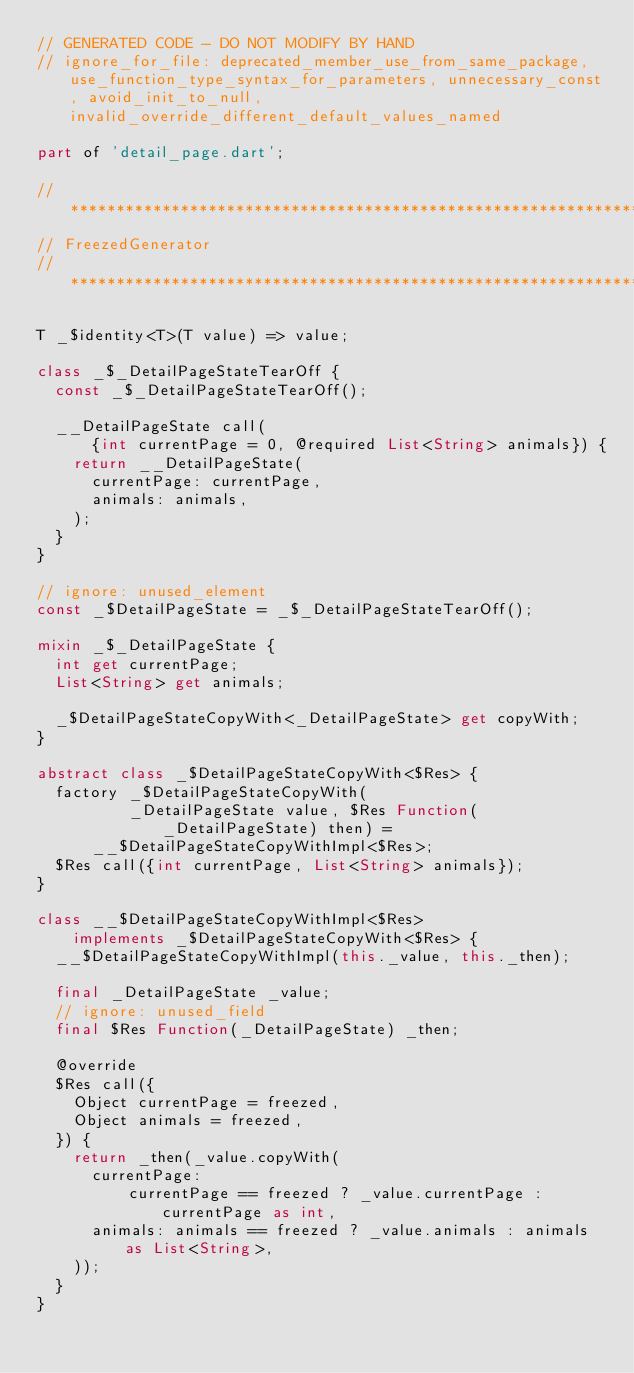<code> <loc_0><loc_0><loc_500><loc_500><_Dart_>// GENERATED CODE - DO NOT MODIFY BY HAND
// ignore_for_file: deprecated_member_use_from_same_package, use_function_type_syntax_for_parameters, unnecessary_const, avoid_init_to_null, invalid_override_different_default_values_named

part of 'detail_page.dart';

// **************************************************************************
// FreezedGenerator
// **************************************************************************

T _$identity<T>(T value) => value;

class _$_DetailPageStateTearOff {
  const _$_DetailPageStateTearOff();

  __DetailPageState call(
      {int currentPage = 0, @required List<String> animals}) {
    return __DetailPageState(
      currentPage: currentPage,
      animals: animals,
    );
  }
}

// ignore: unused_element
const _$DetailPageState = _$_DetailPageStateTearOff();

mixin _$_DetailPageState {
  int get currentPage;
  List<String> get animals;

  _$DetailPageStateCopyWith<_DetailPageState> get copyWith;
}

abstract class _$DetailPageStateCopyWith<$Res> {
  factory _$DetailPageStateCopyWith(
          _DetailPageState value, $Res Function(_DetailPageState) then) =
      __$DetailPageStateCopyWithImpl<$Res>;
  $Res call({int currentPage, List<String> animals});
}

class __$DetailPageStateCopyWithImpl<$Res>
    implements _$DetailPageStateCopyWith<$Res> {
  __$DetailPageStateCopyWithImpl(this._value, this._then);

  final _DetailPageState _value;
  // ignore: unused_field
  final $Res Function(_DetailPageState) _then;

  @override
  $Res call({
    Object currentPage = freezed,
    Object animals = freezed,
  }) {
    return _then(_value.copyWith(
      currentPage:
          currentPage == freezed ? _value.currentPage : currentPage as int,
      animals: animals == freezed ? _value.animals : animals as List<String>,
    ));
  }
}
</code> 